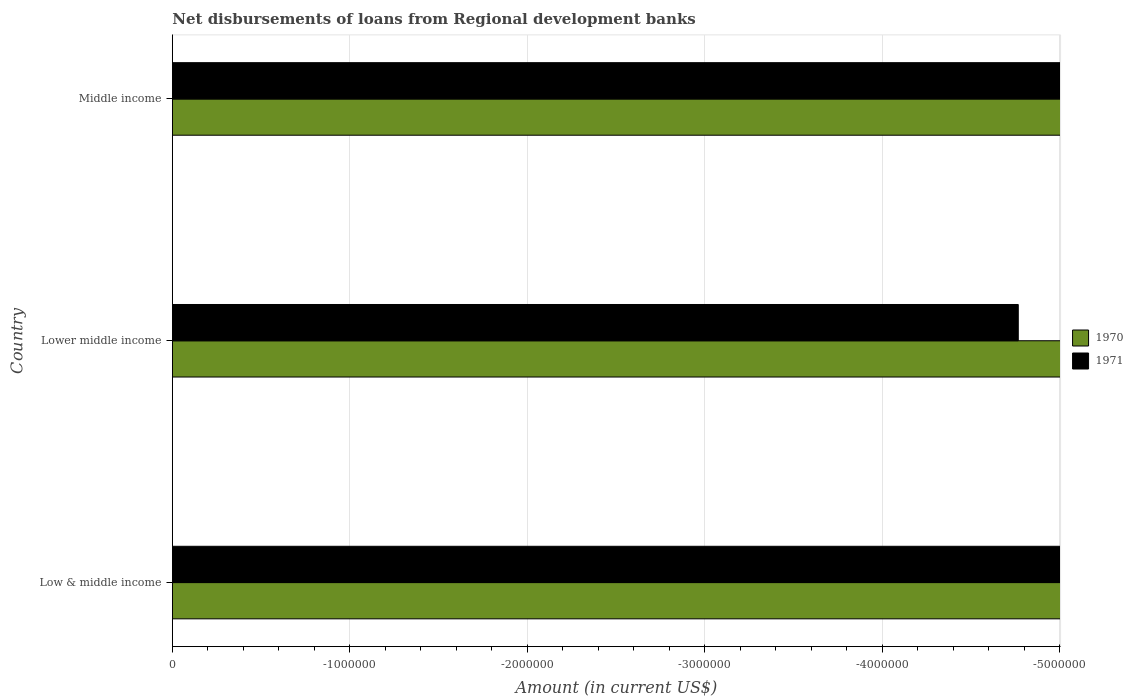How many different coloured bars are there?
Keep it short and to the point. 0. Are the number of bars per tick equal to the number of legend labels?
Your answer should be very brief. No. Are the number of bars on each tick of the Y-axis equal?
Provide a short and direct response. Yes. How many bars are there on the 1st tick from the top?
Offer a very short reply. 0. How many bars are there on the 1st tick from the bottom?
Ensure brevity in your answer.  0. What is the label of the 2nd group of bars from the top?
Keep it short and to the point. Lower middle income. What is the amount of disbursements of loans from regional development banks in 1970 in Middle income?
Provide a succinct answer. 0. Across all countries, what is the minimum amount of disbursements of loans from regional development banks in 1971?
Give a very brief answer. 0. What is the difference between the amount of disbursements of loans from regional development banks in 1971 in Lower middle income and the amount of disbursements of loans from regional development banks in 1970 in Low & middle income?
Offer a terse response. 0. Are all the bars in the graph horizontal?
Offer a terse response. Yes. How many countries are there in the graph?
Provide a succinct answer. 3. What is the difference between two consecutive major ticks on the X-axis?
Keep it short and to the point. 1.00e+06. How are the legend labels stacked?
Provide a succinct answer. Vertical. What is the title of the graph?
Your response must be concise. Net disbursements of loans from Regional development banks. What is the label or title of the X-axis?
Ensure brevity in your answer.  Amount (in current US$). What is the label or title of the Y-axis?
Offer a terse response. Country. What is the Amount (in current US$) in 1970 in Lower middle income?
Keep it short and to the point. 0. What is the total Amount (in current US$) of 1971 in the graph?
Provide a short and direct response. 0. What is the average Amount (in current US$) in 1970 per country?
Your answer should be very brief. 0. What is the average Amount (in current US$) of 1971 per country?
Your answer should be compact. 0. 